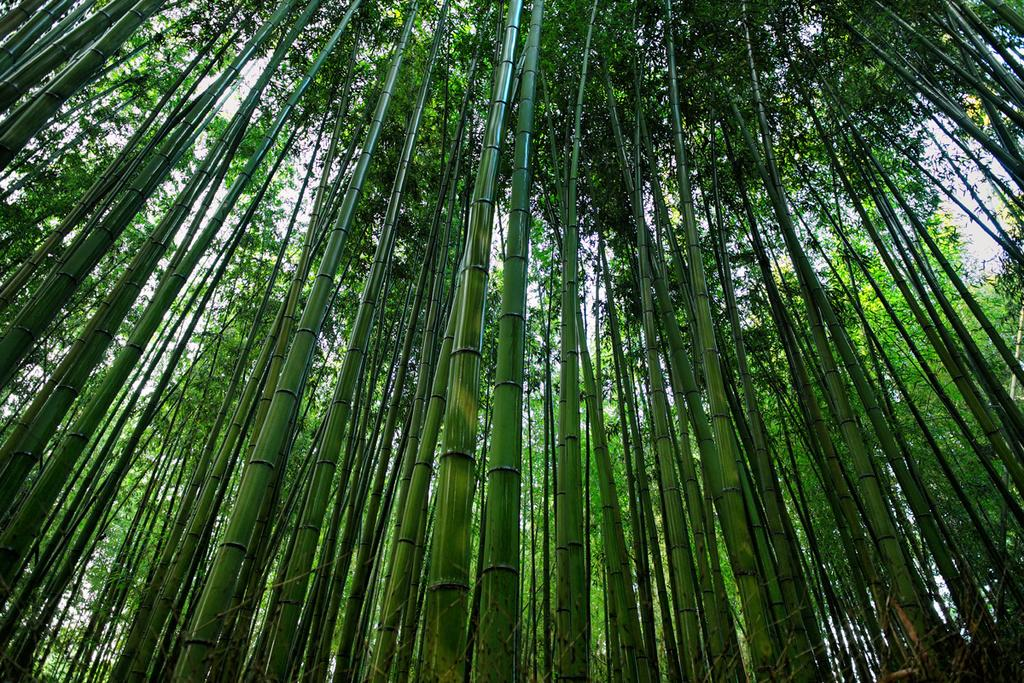What type of vegetation can be seen in the image? There are trees in the image. What part of the natural environment is visible in the image? The sky is visible in the background of the image. Can you see a fork in the image? There is no fork present in the image. What is the desire of the trees in the image? The trees in the image do not have desires, as they are inanimate objects. 